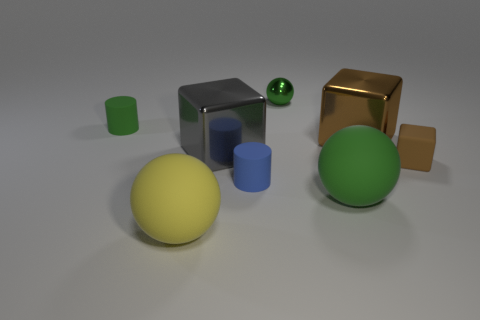Subtract all green cylinders. How many brown cubes are left? 2 Subtract all green balls. How many balls are left? 1 Subtract 1 cubes. How many cubes are left? 2 Add 1 green things. How many objects exist? 9 Subtract all cylinders. How many objects are left? 6 Subtract 1 green cylinders. How many objects are left? 7 Subtract all large yellow spheres. Subtract all small blue matte objects. How many objects are left? 6 Add 2 brown rubber things. How many brown rubber things are left? 3 Add 6 green shiny objects. How many green shiny objects exist? 7 